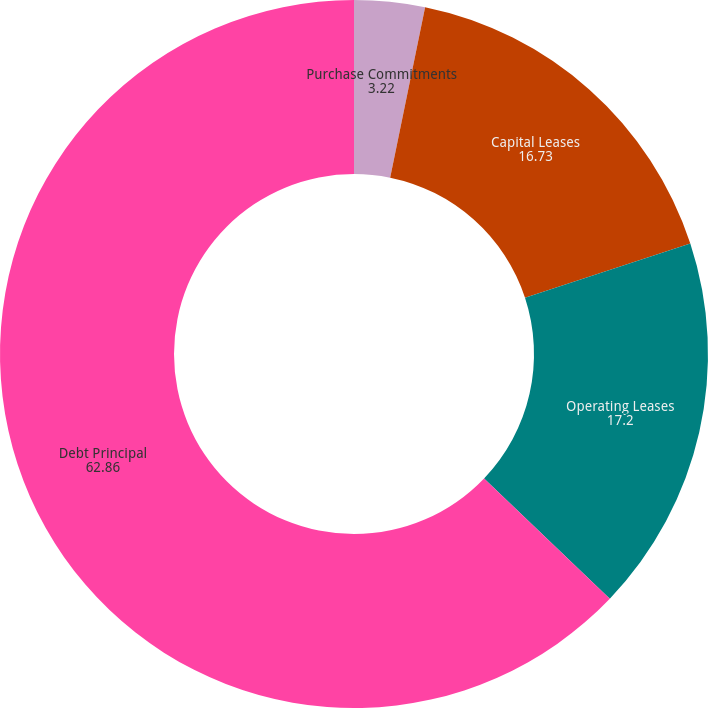Convert chart. <chart><loc_0><loc_0><loc_500><loc_500><pie_chart><fcel>Purchase Commitments<fcel>Capital Leases<fcel>Operating Leases<fcel>Debt Principal<nl><fcel>3.22%<fcel>16.73%<fcel>17.2%<fcel>62.86%<nl></chart> 